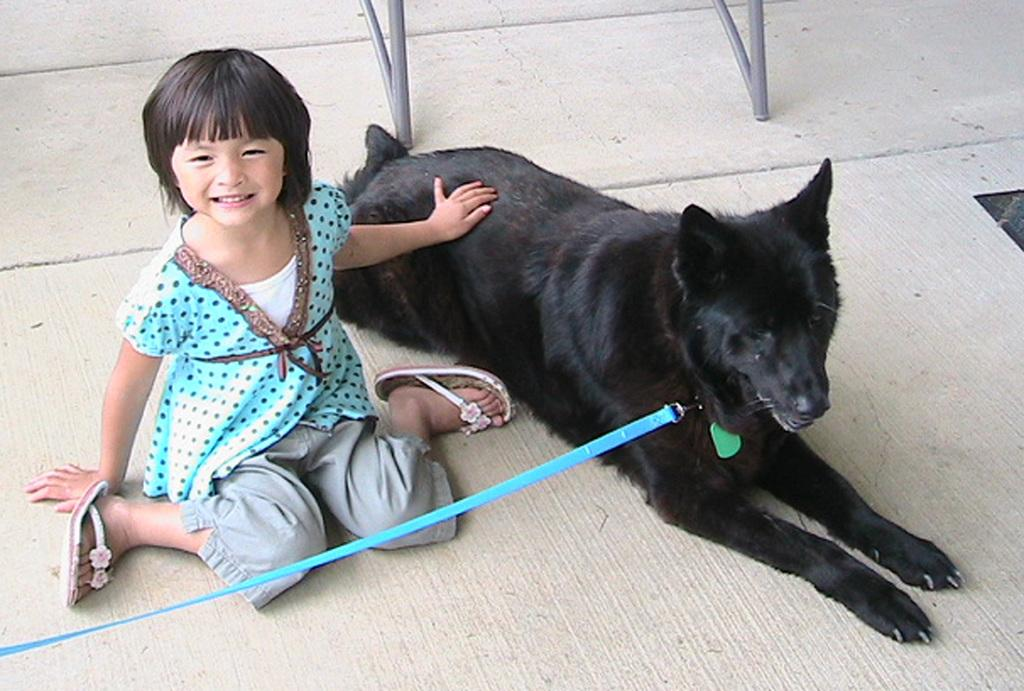What is the main subject of the image? The main subject of the image is a small girl. What is the girl wearing? The girl is wearing a blue dress. What is the girl holding in the image? The girl is holding a black dog. Can you describe the dog's appearance? The dog has a blue color belt attached to it. What can be seen in the background of the image? There is a grey color chair in the background of the image. How many cherries are on the girl's head in the image? There are no cherries present on the girl's head in the image. What riddle does the dog in the image pose to the girl? There is no riddle posed by the dog in the image. 